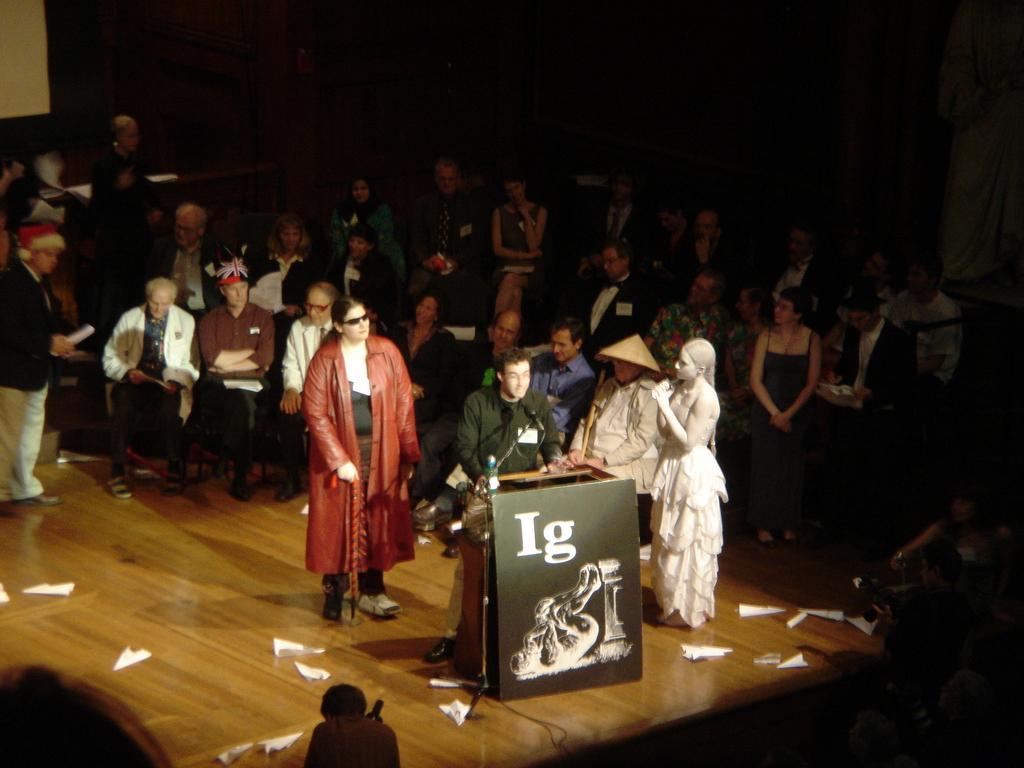Please provide a concise description of this image. In the foreground I can see a crow is sitting on the chairs and few people are standing on the floor, boards. This image is taken may be in a hall. 